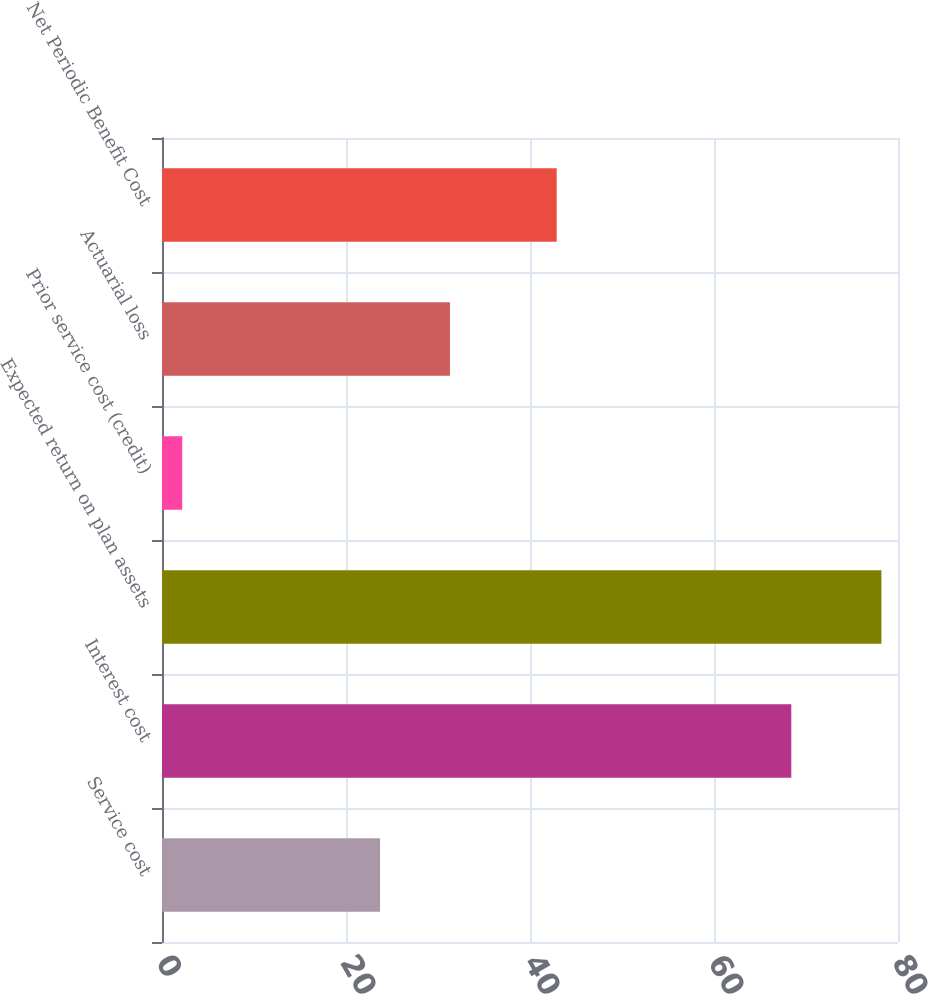Convert chart. <chart><loc_0><loc_0><loc_500><loc_500><bar_chart><fcel>Service cost<fcel>Interest cost<fcel>Expected return on plan assets<fcel>Prior service cost (credit)<fcel>Actuarial loss<fcel>Net Periodic Benefit Cost<nl><fcel>23.7<fcel>68.4<fcel>78.2<fcel>2.2<fcel>31.3<fcel>42.9<nl></chart> 